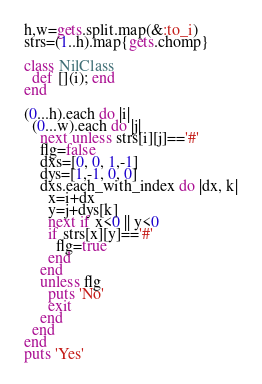Convert code to text. <code><loc_0><loc_0><loc_500><loc_500><_Ruby_>h,w=gets.split.map(&:to_i)
strs=(1..h).map{gets.chomp}

class NilClass
  def [](i); end
end

(0...h).each do |i|
  (0...w).each do |j|
    next unless strs[i][j]=='#'
    flg=false
    dxs=[0, 0, 1,-1]
    dys=[1,-1, 0, 0]
    dxs.each_with_index do |dx, k|
      x=i+dx
      y=j+dys[k]
      next if x<0 || y<0
      if strs[x][y]=='#'
        flg=true
      end
    end
    unless flg
      puts 'No'
      exit
    end
  end
end
puts 'Yes'</code> 